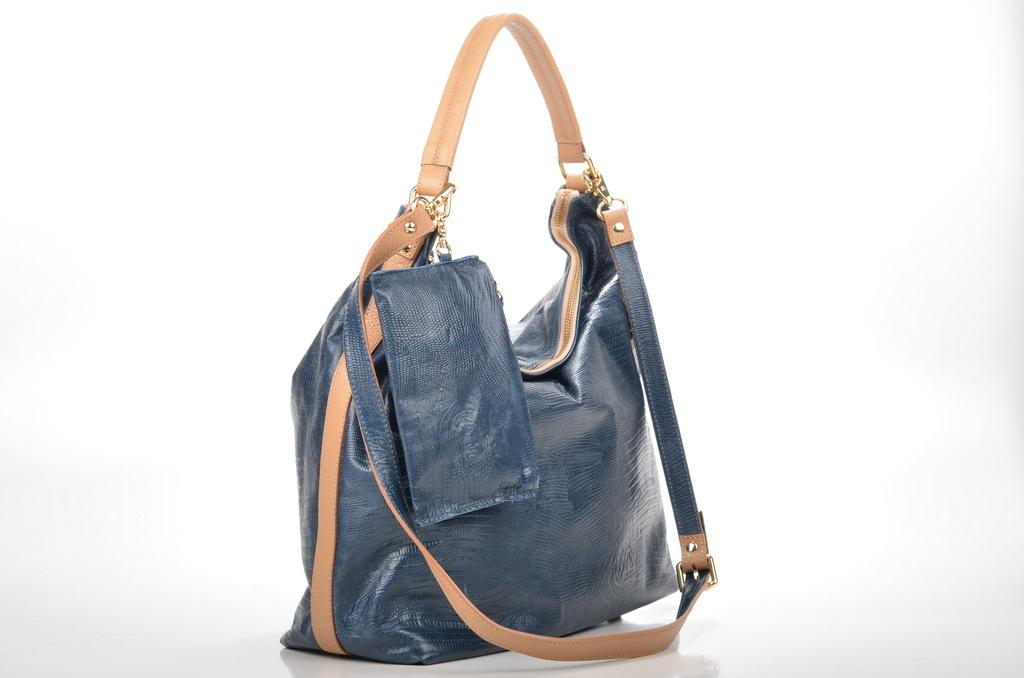What is the primary color of the bag in the image? The primary color of the bag in the image is blue. What additional feature can be seen on the bag? The bag has a chocolate color belt. How does the fog affect the visibility of the bag in the image? There is no fog present in the image, so it does not affect the visibility of the bag. What type of calculator is visible in the image? There is no calculator present in the image. 